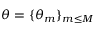Convert formula to latex. <formula><loc_0><loc_0><loc_500><loc_500>\theta = \{ \theta _ { m } \} _ { m \leq M }</formula> 